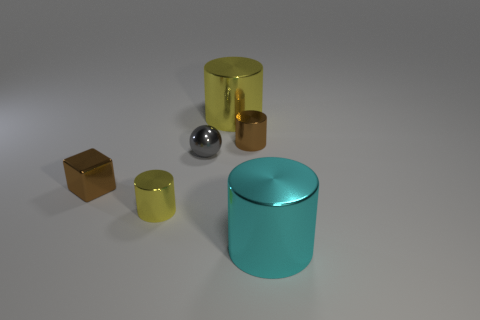Are there any objects of the same color as the metal block?
Give a very brief answer. Yes. There is a brown metallic object that is to the left of the yellow metal cylinder on the left side of the large thing that is behind the tiny yellow cylinder; what is its size?
Your response must be concise. Small. Do the small yellow object and the yellow thing that is behind the metal ball have the same shape?
Offer a terse response. Yes. How many other things are there of the same size as the cyan cylinder?
Make the answer very short. 1. There is a object right of the brown shiny cylinder; what size is it?
Your answer should be compact. Large. What number of tiny things are made of the same material as the cyan cylinder?
Offer a terse response. 4. There is a big thing behind the large cyan metallic thing; is its shape the same as the small yellow thing?
Your answer should be very brief. Yes. There is a tiny brown metal thing in front of the sphere; what is its shape?
Provide a short and direct response. Cube. What is the size of the thing that is the same color as the metallic block?
Provide a succinct answer. Small. What material is the tiny yellow cylinder?
Give a very brief answer. Metal. 